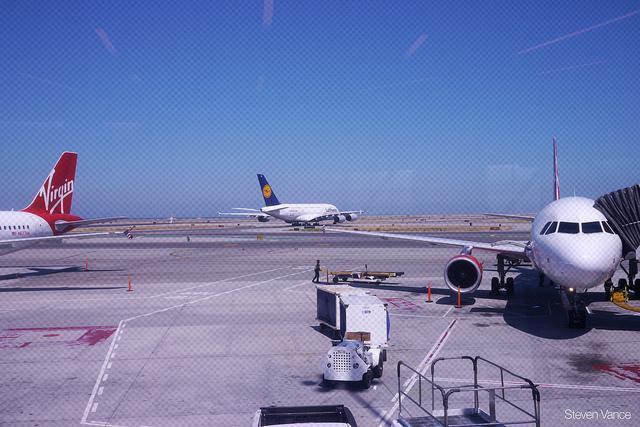How many planes?
Give a very brief answer. 3. 